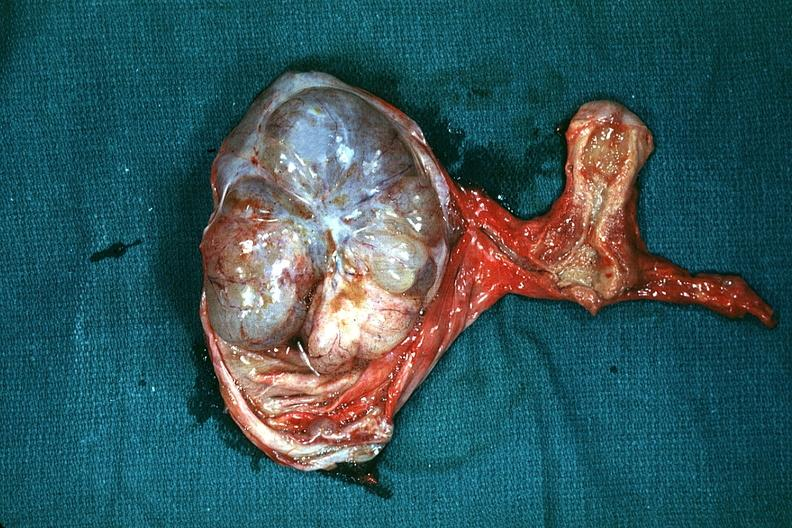what is present?
Answer the question using a single word or phrase. Mucinous cystadenocarcinoma 